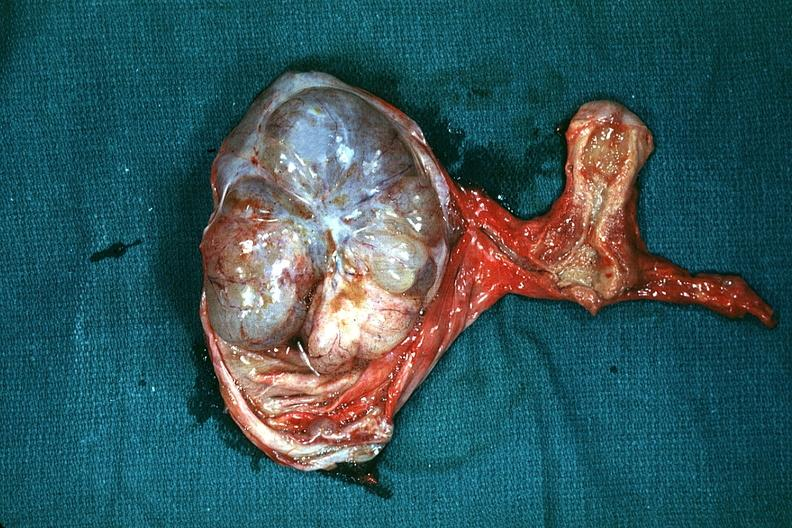what is present?
Answer the question using a single word or phrase. Mucinous cystadenocarcinoma 